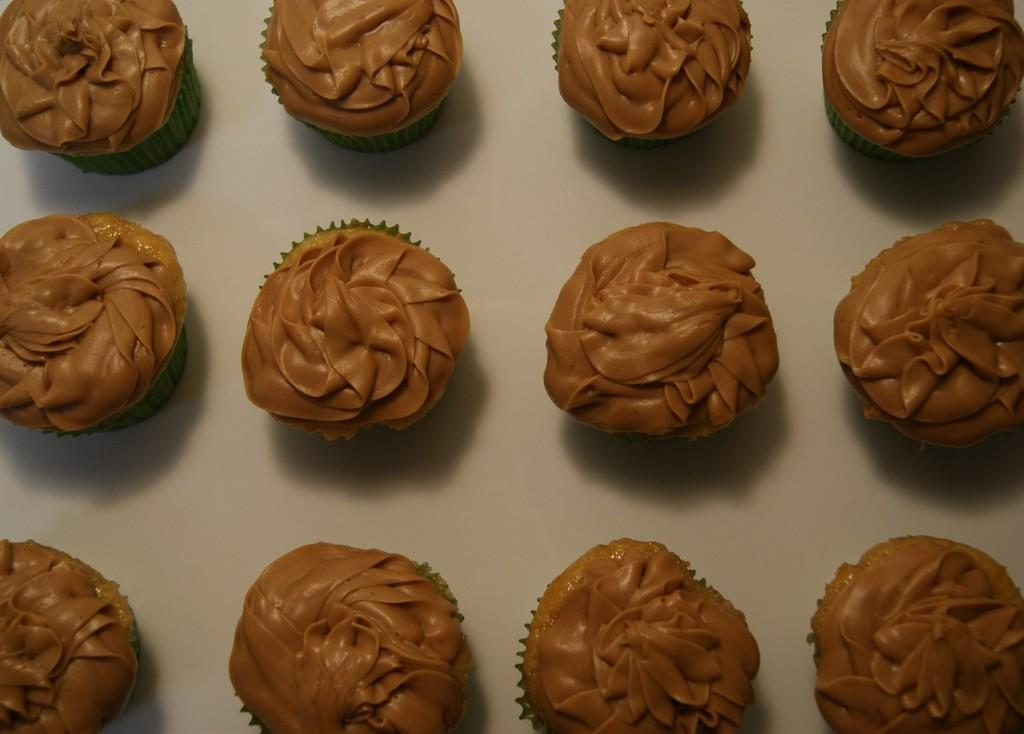What type of dessert can be seen in the image? There are cupcakes in the image. What is the color of the surface on which the cupcakes are placed? The cupcakes are on a white surface. What type of bat can be seen flying around the cupcakes in the image? There is no bat present in the image; it only features cupcakes on a white surface. 